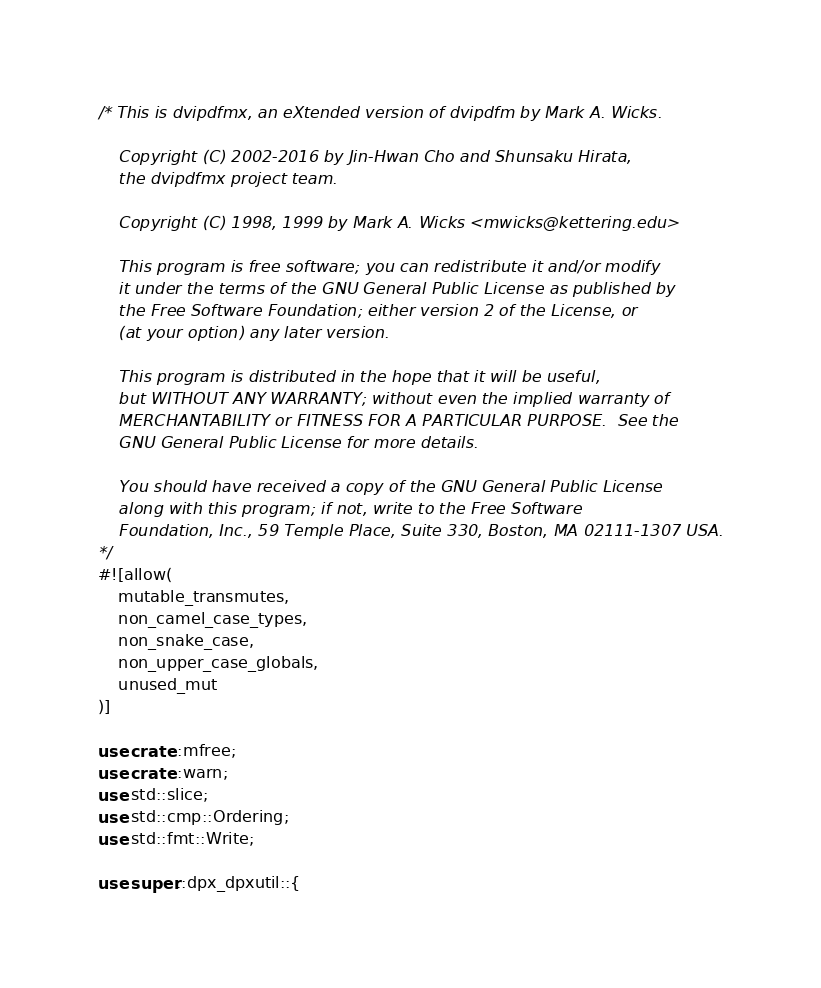<code> <loc_0><loc_0><loc_500><loc_500><_Rust_>/* This is dvipdfmx, an eXtended version of dvipdfm by Mark A. Wicks.

    Copyright (C) 2002-2016 by Jin-Hwan Cho and Shunsaku Hirata,
    the dvipdfmx project team.

    Copyright (C) 1998, 1999 by Mark A. Wicks <mwicks@kettering.edu>

    This program is free software; you can redistribute it and/or modify
    it under the terms of the GNU General Public License as published by
    the Free Software Foundation; either version 2 of the License, or
    (at your option) any later version.

    This program is distributed in the hope that it will be useful,
    but WITHOUT ANY WARRANTY; without even the implied warranty of
    MERCHANTABILITY or FITNESS FOR A PARTICULAR PURPOSE.  See the
    GNU General Public License for more details.

    You should have received a copy of the GNU General Public License
    along with this program; if not, write to the Free Software
    Foundation, Inc., 59 Temple Place, Suite 330, Boston, MA 02111-1307 USA.
*/
#![allow(
    mutable_transmutes,
    non_camel_case_types,
    non_snake_case,
    non_upper_case_globals,
    unused_mut
)]

use crate::mfree;
use crate::warn;
use std::slice;
use std::cmp::Ordering;
use std::fmt::Write;

use super::dpx_dpxutil::{</code> 